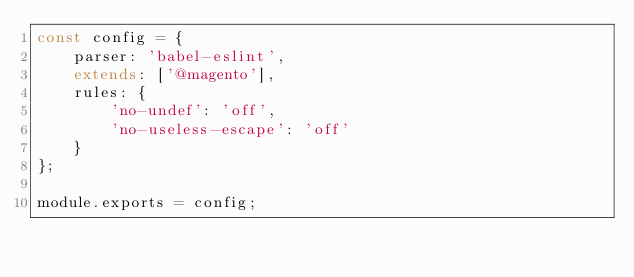<code> <loc_0><loc_0><loc_500><loc_500><_JavaScript_>const config = {
    parser: 'babel-eslint',
    extends: ['@magento'],
    rules: {
        'no-undef': 'off',
        'no-useless-escape': 'off'
    }
};

module.exports = config;
</code> 